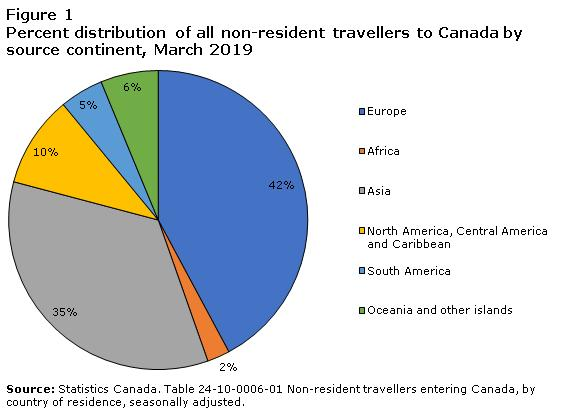Identify some key points in this picture. As of March 2019, 42% of non-resident travelers from Europe were entering Canada. In March 2019, approximately 5% of non-resident travelers from South America entered Canada. As of March 2019, 35% of non-resident travellers from Asia were entering Canada. 